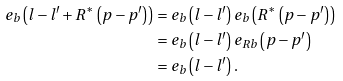<formula> <loc_0><loc_0><loc_500><loc_500>e _ { b } \left ( l - l ^ { \prime } + R ^ { \ast } \left ( p - p ^ { \prime } \right ) \right ) & = e _ { b } \left ( l - l ^ { \prime } \right ) e _ { b } \left ( R ^ { \ast } \left ( p - p ^ { \prime } \right ) \right ) \\ & = e _ { b } \left ( l - l ^ { \prime } \right ) e _ { R b } \left ( p - p ^ { \prime } \right ) \\ & = e _ { b } \left ( l - l ^ { \prime } \right ) .</formula> 